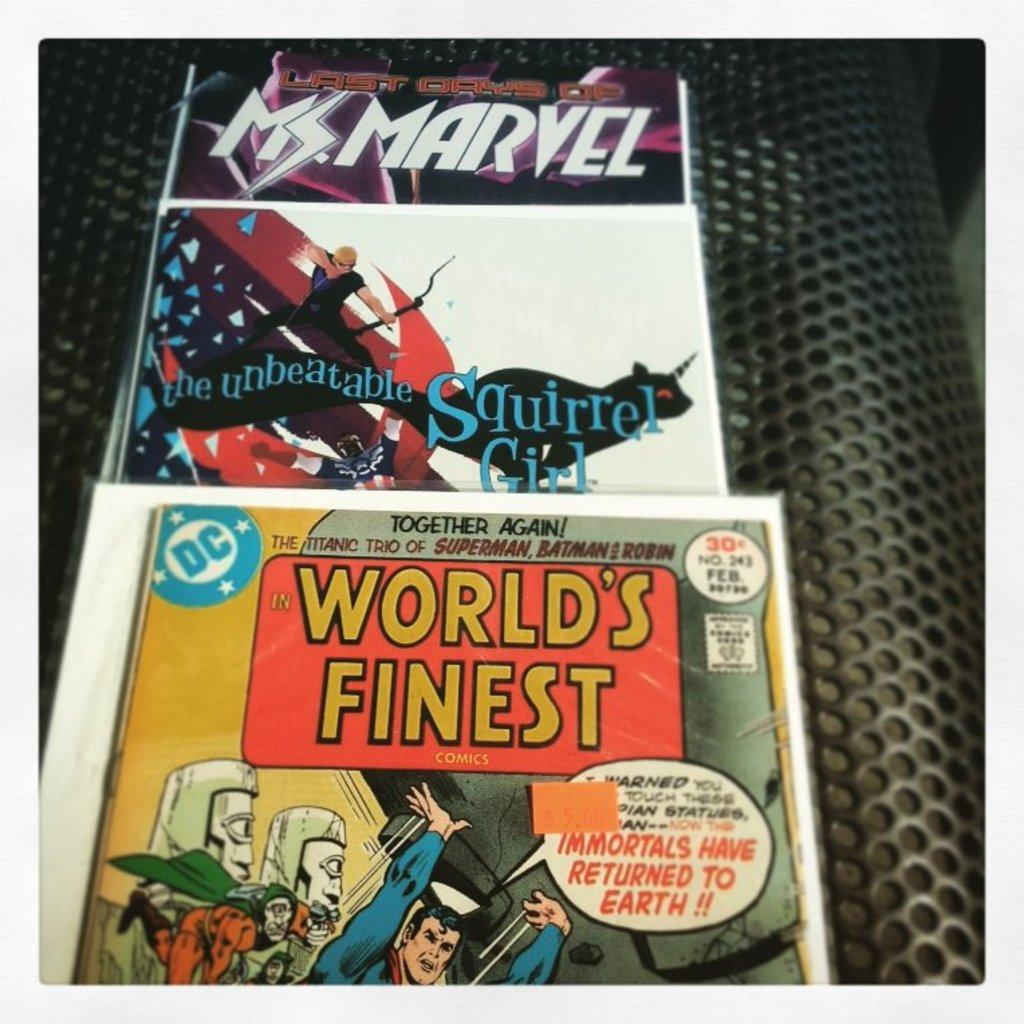<image>
Provide a brief description of the given image. Several movies on display including the unbeatable Squirrel Girl 